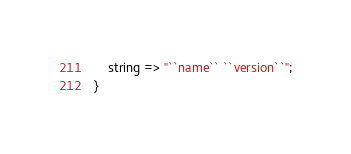Convert code to text. <code><loc_0><loc_0><loc_500><loc_500><_Ceylon_>	string => "``name`` ``version``";
}
</code> 